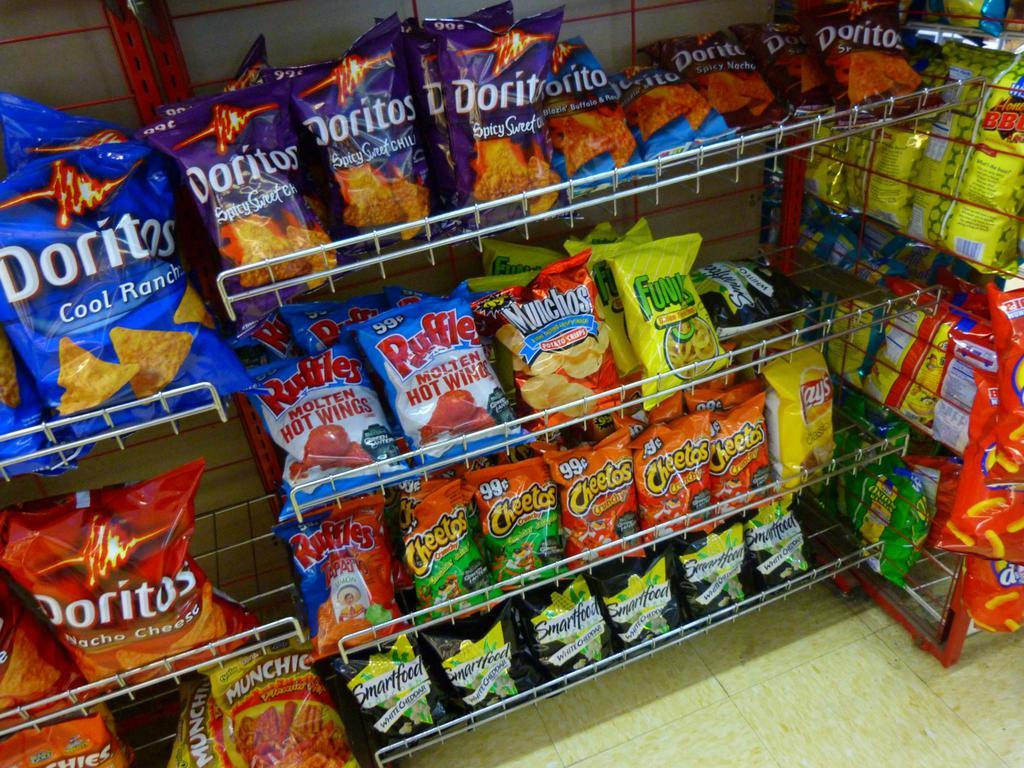Provide a one-sentence caption for the provided image. Bags of chips are organized on shelves with the Flaming Hot Munchies in the bottom left. 